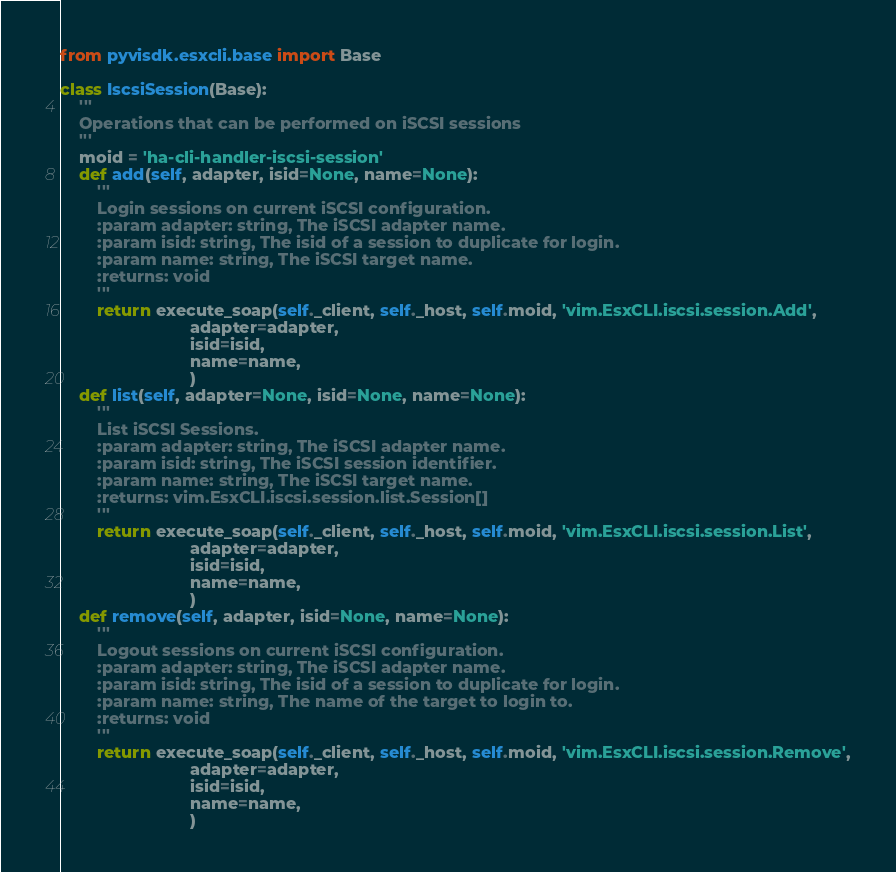<code> <loc_0><loc_0><loc_500><loc_500><_Python_>from pyvisdk.esxcli.base import Base

class IscsiSession(Base):
    '''
    Operations that can be performed on iSCSI sessions
    '''
    moid = 'ha-cli-handler-iscsi-session'
    def add(self, adapter, isid=None, name=None):
        '''
        Login sessions on current iSCSI configuration.
        :param adapter: string, The iSCSI adapter name.
        :param isid: string, The isid of a session to duplicate for login.
        :param name: string, The iSCSI target name.
        :returns: void
        '''
        return execute_soap(self._client, self._host, self.moid, 'vim.EsxCLI.iscsi.session.Add',
                            adapter=adapter,
                            isid=isid,
                            name=name,
                            )
    def list(self, adapter=None, isid=None, name=None):
        '''
        List iSCSI Sessions.
        :param adapter: string, The iSCSI adapter name.
        :param isid: string, The iSCSI session identifier.
        :param name: string, The iSCSI target name.
        :returns: vim.EsxCLI.iscsi.session.list.Session[]
        '''
        return execute_soap(self._client, self._host, self.moid, 'vim.EsxCLI.iscsi.session.List',
                            adapter=adapter,
                            isid=isid,
                            name=name,
                            )
    def remove(self, adapter, isid=None, name=None):
        '''
        Logout sessions on current iSCSI configuration.
        :param adapter: string, The iSCSI adapter name.
        :param isid: string, The isid of a session to duplicate for login.
        :param name: string, The name of the target to login to.
        :returns: void
        '''
        return execute_soap(self._client, self._host, self.moid, 'vim.EsxCLI.iscsi.session.Remove',
                            adapter=adapter,
                            isid=isid,
                            name=name,
                            )   </code> 